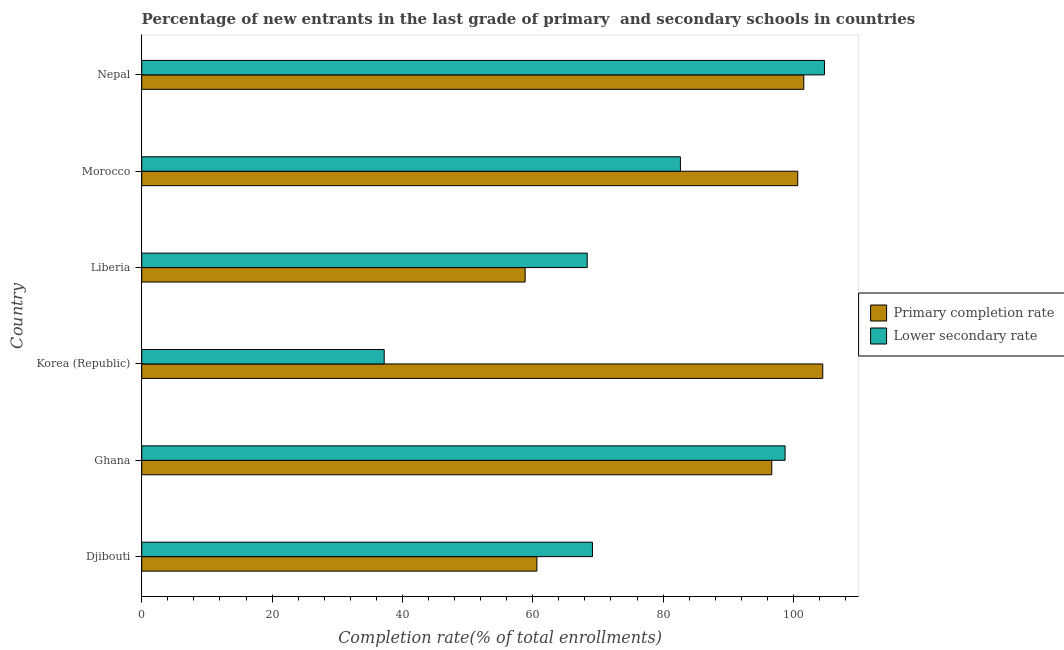How many groups of bars are there?
Your response must be concise. 6. Are the number of bars per tick equal to the number of legend labels?
Your answer should be compact. Yes. How many bars are there on the 2nd tick from the bottom?
Your answer should be compact. 2. What is the label of the 1st group of bars from the top?
Make the answer very short. Nepal. In how many cases, is the number of bars for a given country not equal to the number of legend labels?
Your answer should be very brief. 0. What is the completion rate in secondary schools in Morocco?
Keep it short and to the point. 82.66. Across all countries, what is the maximum completion rate in secondary schools?
Keep it short and to the point. 104.76. Across all countries, what is the minimum completion rate in primary schools?
Your answer should be compact. 58.83. In which country was the completion rate in secondary schools maximum?
Make the answer very short. Nepal. In which country was the completion rate in secondary schools minimum?
Offer a very short reply. Korea (Republic). What is the total completion rate in primary schools in the graph?
Make the answer very short. 522.91. What is the difference between the completion rate in secondary schools in Ghana and that in Nepal?
Offer a very short reply. -6.04. What is the difference between the completion rate in primary schools in Ghana and the completion rate in secondary schools in Korea (Republic)?
Offer a terse response. 59.47. What is the average completion rate in secondary schools per country?
Provide a succinct answer. 76.81. What is the difference between the completion rate in secondary schools and completion rate in primary schools in Morocco?
Your answer should be very brief. -18. In how many countries, is the completion rate in secondary schools greater than 84 %?
Keep it short and to the point. 2. What is the ratio of the completion rate in secondary schools in Djibouti to that in Ghana?
Give a very brief answer. 0.7. Is the completion rate in secondary schools in Ghana less than that in Korea (Republic)?
Ensure brevity in your answer.  No. What is the difference between the highest and the second highest completion rate in secondary schools?
Your answer should be compact. 6.04. What is the difference between the highest and the lowest completion rate in primary schools?
Make the answer very short. 45.67. Is the sum of the completion rate in primary schools in Korea (Republic) and Liberia greater than the maximum completion rate in secondary schools across all countries?
Provide a succinct answer. Yes. What does the 1st bar from the top in Morocco represents?
Provide a succinct answer. Lower secondary rate. What does the 2nd bar from the bottom in Korea (Republic) represents?
Your answer should be very brief. Lower secondary rate. How many bars are there?
Provide a succinct answer. 12. How many countries are there in the graph?
Provide a succinct answer. 6. How many legend labels are there?
Offer a terse response. 2. What is the title of the graph?
Keep it short and to the point. Percentage of new entrants in the last grade of primary  and secondary schools in countries. Does "Official creditors" appear as one of the legend labels in the graph?
Your response must be concise. No. What is the label or title of the X-axis?
Keep it short and to the point. Completion rate(% of total enrollments). What is the Completion rate(% of total enrollments) of Primary completion rate in Djibouti?
Your answer should be very brief. 60.64. What is the Completion rate(% of total enrollments) in Lower secondary rate in Djibouti?
Your response must be concise. 69.16. What is the Completion rate(% of total enrollments) in Primary completion rate in Ghana?
Ensure brevity in your answer.  96.68. What is the Completion rate(% of total enrollments) of Lower secondary rate in Ghana?
Your answer should be compact. 98.72. What is the Completion rate(% of total enrollments) in Primary completion rate in Korea (Republic)?
Give a very brief answer. 104.5. What is the Completion rate(% of total enrollments) of Lower secondary rate in Korea (Republic)?
Your answer should be compact. 37.21. What is the Completion rate(% of total enrollments) of Primary completion rate in Liberia?
Your response must be concise. 58.83. What is the Completion rate(% of total enrollments) in Lower secondary rate in Liberia?
Your response must be concise. 68.36. What is the Completion rate(% of total enrollments) of Primary completion rate in Morocco?
Provide a short and direct response. 100.66. What is the Completion rate(% of total enrollments) of Lower secondary rate in Morocco?
Offer a very short reply. 82.66. What is the Completion rate(% of total enrollments) in Primary completion rate in Nepal?
Keep it short and to the point. 101.59. What is the Completion rate(% of total enrollments) of Lower secondary rate in Nepal?
Provide a short and direct response. 104.76. Across all countries, what is the maximum Completion rate(% of total enrollments) of Primary completion rate?
Provide a short and direct response. 104.5. Across all countries, what is the maximum Completion rate(% of total enrollments) of Lower secondary rate?
Provide a short and direct response. 104.76. Across all countries, what is the minimum Completion rate(% of total enrollments) in Primary completion rate?
Your answer should be compact. 58.83. Across all countries, what is the minimum Completion rate(% of total enrollments) of Lower secondary rate?
Your answer should be compact. 37.21. What is the total Completion rate(% of total enrollments) in Primary completion rate in the graph?
Offer a terse response. 522.91. What is the total Completion rate(% of total enrollments) in Lower secondary rate in the graph?
Ensure brevity in your answer.  460.87. What is the difference between the Completion rate(% of total enrollments) in Primary completion rate in Djibouti and that in Ghana?
Give a very brief answer. -36.04. What is the difference between the Completion rate(% of total enrollments) of Lower secondary rate in Djibouti and that in Ghana?
Give a very brief answer. -29.56. What is the difference between the Completion rate(% of total enrollments) of Primary completion rate in Djibouti and that in Korea (Republic)?
Provide a succinct answer. -43.86. What is the difference between the Completion rate(% of total enrollments) of Lower secondary rate in Djibouti and that in Korea (Republic)?
Your answer should be compact. 31.96. What is the difference between the Completion rate(% of total enrollments) in Primary completion rate in Djibouti and that in Liberia?
Offer a terse response. 1.81. What is the difference between the Completion rate(% of total enrollments) of Lower secondary rate in Djibouti and that in Liberia?
Your answer should be very brief. 0.8. What is the difference between the Completion rate(% of total enrollments) of Primary completion rate in Djibouti and that in Morocco?
Ensure brevity in your answer.  -40.03. What is the difference between the Completion rate(% of total enrollments) in Lower secondary rate in Djibouti and that in Morocco?
Offer a terse response. -13.5. What is the difference between the Completion rate(% of total enrollments) of Primary completion rate in Djibouti and that in Nepal?
Provide a succinct answer. -40.95. What is the difference between the Completion rate(% of total enrollments) in Lower secondary rate in Djibouti and that in Nepal?
Provide a short and direct response. -35.6. What is the difference between the Completion rate(% of total enrollments) in Primary completion rate in Ghana and that in Korea (Republic)?
Keep it short and to the point. -7.82. What is the difference between the Completion rate(% of total enrollments) in Lower secondary rate in Ghana and that in Korea (Republic)?
Make the answer very short. 61.51. What is the difference between the Completion rate(% of total enrollments) of Primary completion rate in Ghana and that in Liberia?
Make the answer very short. 37.85. What is the difference between the Completion rate(% of total enrollments) of Lower secondary rate in Ghana and that in Liberia?
Make the answer very short. 30.36. What is the difference between the Completion rate(% of total enrollments) of Primary completion rate in Ghana and that in Morocco?
Your answer should be compact. -3.98. What is the difference between the Completion rate(% of total enrollments) in Lower secondary rate in Ghana and that in Morocco?
Provide a short and direct response. 16.06. What is the difference between the Completion rate(% of total enrollments) of Primary completion rate in Ghana and that in Nepal?
Keep it short and to the point. -4.91. What is the difference between the Completion rate(% of total enrollments) in Lower secondary rate in Ghana and that in Nepal?
Your answer should be compact. -6.04. What is the difference between the Completion rate(% of total enrollments) in Primary completion rate in Korea (Republic) and that in Liberia?
Offer a terse response. 45.67. What is the difference between the Completion rate(% of total enrollments) in Lower secondary rate in Korea (Republic) and that in Liberia?
Give a very brief answer. -31.15. What is the difference between the Completion rate(% of total enrollments) in Primary completion rate in Korea (Republic) and that in Morocco?
Your response must be concise. 3.84. What is the difference between the Completion rate(% of total enrollments) in Lower secondary rate in Korea (Republic) and that in Morocco?
Provide a short and direct response. -45.45. What is the difference between the Completion rate(% of total enrollments) of Primary completion rate in Korea (Republic) and that in Nepal?
Make the answer very short. 2.91. What is the difference between the Completion rate(% of total enrollments) of Lower secondary rate in Korea (Republic) and that in Nepal?
Provide a short and direct response. -67.56. What is the difference between the Completion rate(% of total enrollments) in Primary completion rate in Liberia and that in Morocco?
Offer a terse response. -41.83. What is the difference between the Completion rate(% of total enrollments) in Lower secondary rate in Liberia and that in Morocco?
Offer a very short reply. -14.3. What is the difference between the Completion rate(% of total enrollments) in Primary completion rate in Liberia and that in Nepal?
Ensure brevity in your answer.  -42.76. What is the difference between the Completion rate(% of total enrollments) in Lower secondary rate in Liberia and that in Nepal?
Offer a terse response. -36.4. What is the difference between the Completion rate(% of total enrollments) in Primary completion rate in Morocco and that in Nepal?
Offer a terse response. -0.93. What is the difference between the Completion rate(% of total enrollments) of Lower secondary rate in Morocco and that in Nepal?
Your answer should be compact. -22.1. What is the difference between the Completion rate(% of total enrollments) in Primary completion rate in Djibouti and the Completion rate(% of total enrollments) in Lower secondary rate in Ghana?
Your response must be concise. -38.08. What is the difference between the Completion rate(% of total enrollments) in Primary completion rate in Djibouti and the Completion rate(% of total enrollments) in Lower secondary rate in Korea (Republic)?
Give a very brief answer. 23.43. What is the difference between the Completion rate(% of total enrollments) in Primary completion rate in Djibouti and the Completion rate(% of total enrollments) in Lower secondary rate in Liberia?
Offer a terse response. -7.72. What is the difference between the Completion rate(% of total enrollments) of Primary completion rate in Djibouti and the Completion rate(% of total enrollments) of Lower secondary rate in Morocco?
Ensure brevity in your answer.  -22.02. What is the difference between the Completion rate(% of total enrollments) of Primary completion rate in Djibouti and the Completion rate(% of total enrollments) of Lower secondary rate in Nepal?
Provide a short and direct response. -44.12. What is the difference between the Completion rate(% of total enrollments) of Primary completion rate in Ghana and the Completion rate(% of total enrollments) of Lower secondary rate in Korea (Republic)?
Your answer should be very brief. 59.47. What is the difference between the Completion rate(% of total enrollments) in Primary completion rate in Ghana and the Completion rate(% of total enrollments) in Lower secondary rate in Liberia?
Make the answer very short. 28.32. What is the difference between the Completion rate(% of total enrollments) of Primary completion rate in Ghana and the Completion rate(% of total enrollments) of Lower secondary rate in Morocco?
Ensure brevity in your answer.  14.02. What is the difference between the Completion rate(% of total enrollments) of Primary completion rate in Ghana and the Completion rate(% of total enrollments) of Lower secondary rate in Nepal?
Keep it short and to the point. -8.08. What is the difference between the Completion rate(% of total enrollments) in Primary completion rate in Korea (Republic) and the Completion rate(% of total enrollments) in Lower secondary rate in Liberia?
Your response must be concise. 36.14. What is the difference between the Completion rate(% of total enrollments) of Primary completion rate in Korea (Republic) and the Completion rate(% of total enrollments) of Lower secondary rate in Morocco?
Keep it short and to the point. 21.84. What is the difference between the Completion rate(% of total enrollments) in Primary completion rate in Korea (Republic) and the Completion rate(% of total enrollments) in Lower secondary rate in Nepal?
Ensure brevity in your answer.  -0.26. What is the difference between the Completion rate(% of total enrollments) of Primary completion rate in Liberia and the Completion rate(% of total enrollments) of Lower secondary rate in Morocco?
Make the answer very short. -23.83. What is the difference between the Completion rate(% of total enrollments) of Primary completion rate in Liberia and the Completion rate(% of total enrollments) of Lower secondary rate in Nepal?
Your response must be concise. -45.93. What is the difference between the Completion rate(% of total enrollments) in Primary completion rate in Morocco and the Completion rate(% of total enrollments) in Lower secondary rate in Nepal?
Offer a terse response. -4.1. What is the average Completion rate(% of total enrollments) in Primary completion rate per country?
Offer a terse response. 87.15. What is the average Completion rate(% of total enrollments) in Lower secondary rate per country?
Keep it short and to the point. 76.81. What is the difference between the Completion rate(% of total enrollments) of Primary completion rate and Completion rate(% of total enrollments) of Lower secondary rate in Djibouti?
Give a very brief answer. -8.52. What is the difference between the Completion rate(% of total enrollments) in Primary completion rate and Completion rate(% of total enrollments) in Lower secondary rate in Ghana?
Your answer should be compact. -2.04. What is the difference between the Completion rate(% of total enrollments) in Primary completion rate and Completion rate(% of total enrollments) in Lower secondary rate in Korea (Republic)?
Offer a very short reply. 67.3. What is the difference between the Completion rate(% of total enrollments) of Primary completion rate and Completion rate(% of total enrollments) of Lower secondary rate in Liberia?
Provide a succinct answer. -9.53. What is the difference between the Completion rate(% of total enrollments) of Primary completion rate and Completion rate(% of total enrollments) of Lower secondary rate in Morocco?
Ensure brevity in your answer.  18.01. What is the difference between the Completion rate(% of total enrollments) in Primary completion rate and Completion rate(% of total enrollments) in Lower secondary rate in Nepal?
Your answer should be compact. -3.17. What is the ratio of the Completion rate(% of total enrollments) of Primary completion rate in Djibouti to that in Ghana?
Provide a succinct answer. 0.63. What is the ratio of the Completion rate(% of total enrollments) of Lower secondary rate in Djibouti to that in Ghana?
Your response must be concise. 0.7. What is the ratio of the Completion rate(% of total enrollments) of Primary completion rate in Djibouti to that in Korea (Republic)?
Provide a succinct answer. 0.58. What is the ratio of the Completion rate(% of total enrollments) in Lower secondary rate in Djibouti to that in Korea (Republic)?
Provide a short and direct response. 1.86. What is the ratio of the Completion rate(% of total enrollments) of Primary completion rate in Djibouti to that in Liberia?
Offer a terse response. 1.03. What is the ratio of the Completion rate(% of total enrollments) in Lower secondary rate in Djibouti to that in Liberia?
Your answer should be very brief. 1.01. What is the ratio of the Completion rate(% of total enrollments) of Primary completion rate in Djibouti to that in Morocco?
Your response must be concise. 0.6. What is the ratio of the Completion rate(% of total enrollments) of Lower secondary rate in Djibouti to that in Morocco?
Your answer should be very brief. 0.84. What is the ratio of the Completion rate(% of total enrollments) in Primary completion rate in Djibouti to that in Nepal?
Give a very brief answer. 0.6. What is the ratio of the Completion rate(% of total enrollments) of Lower secondary rate in Djibouti to that in Nepal?
Provide a short and direct response. 0.66. What is the ratio of the Completion rate(% of total enrollments) in Primary completion rate in Ghana to that in Korea (Republic)?
Your answer should be compact. 0.93. What is the ratio of the Completion rate(% of total enrollments) in Lower secondary rate in Ghana to that in Korea (Republic)?
Provide a short and direct response. 2.65. What is the ratio of the Completion rate(% of total enrollments) of Primary completion rate in Ghana to that in Liberia?
Your answer should be compact. 1.64. What is the ratio of the Completion rate(% of total enrollments) of Lower secondary rate in Ghana to that in Liberia?
Provide a succinct answer. 1.44. What is the ratio of the Completion rate(% of total enrollments) in Primary completion rate in Ghana to that in Morocco?
Offer a terse response. 0.96. What is the ratio of the Completion rate(% of total enrollments) in Lower secondary rate in Ghana to that in Morocco?
Provide a succinct answer. 1.19. What is the ratio of the Completion rate(% of total enrollments) in Primary completion rate in Ghana to that in Nepal?
Give a very brief answer. 0.95. What is the ratio of the Completion rate(% of total enrollments) in Lower secondary rate in Ghana to that in Nepal?
Your answer should be very brief. 0.94. What is the ratio of the Completion rate(% of total enrollments) in Primary completion rate in Korea (Republic) to that in Liberia?
Your answer should be very brief. 1.78. What is the ratio of the Completion rate(% of total enrollments) in Lower secondary rate in Korea (Republic) to that in Liberia?
Keep it short and to the point. 0.54. What is the ratio of the Completion rate(% of total enrollments) of Primary completion rate in Korea (Republic) to that in Morocco?
Give a very brief answer. 1.04. What is the ratio of the Completion rate(% of total enrollments) of Lower secondary rate in Korea (Republic) to that in Morocco?
Ensure brevity in your answer.  0.45. What is the ratio of the Completion rate(% of total enrollments) in Primary completion rate in Korea (Republic) to that in Nepal?
Give a very brief answer. 1.03. What is the ratio of the Completion rate(% of total enrollments) of Lower secondary rate in Korea (Republic) to that in Nepal?
Your answer should be compact. 0.36. What is the ratio of the Completion rate(% of total enrollments) of Primary completion rate in Liberia to that in Morocco?
Your answer should be compact. 0.58. What is the ratio of the Completion rate(% of total enrollments) in Lower secondary rate in Liberia to that in Morocco?
Keep it short and to the point. 0.83. What is the ratio of the Completion rate(% of total enrollments) of Primary completion rate in Liberia to that in Nepal?
Provide a short and direct response. 0.58. What is the ratio of the Completion rate(% of total enrollments) in Lower secondary rate in Liberia to that in Nepal?
Provide a succinct answer. 0.65. What is the ratio of the Completion rate(% of total enrollments) in Primary completion rate in Morocco to that in Nepal?
Offer a terse response. 0.99. What is the ratio of the Completion rate(% of total enrollments) in Lower secondary rate in Morocco to that in Nepal?
Provide a short and direct response. 0.79. What is the difference between the highest and the second highest Completion rate(% of total enrollments) in Primary completion rate?
Offer a terse response. 2.91. What is the difference between the highest and the second highest Completion rate(% of total enrollments) in Lower secondary rate?
Offer a terse response. 6.04. What is the difference between the highest and the lowest Completion rate(% of total enrollments) of Primary completion rate?
Give a very brief answer. 45.67. What is the difference between the highest and the lowest Completion rate(% of total enrollments) of Lower secondary rate?
Provide a short and direct response. 67.56. 